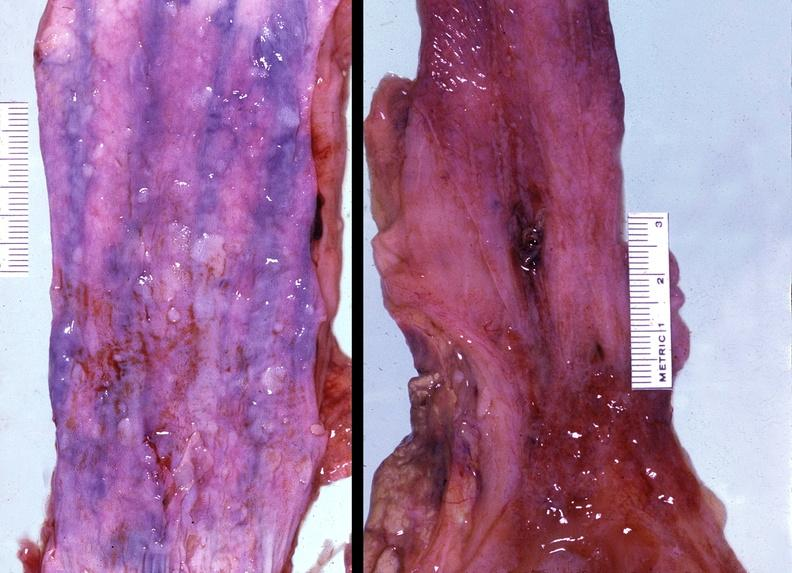does cytomegalovirus show esophagus, varices?
Answer the question using a single word or phrase. No 